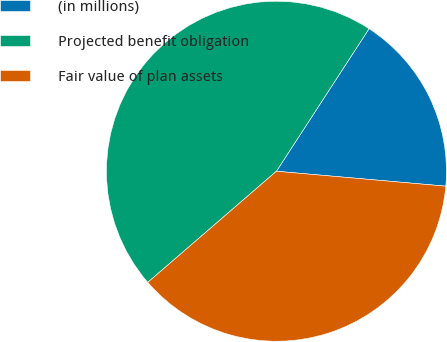Convert chart. <chart><loc_0><loc_0><loc_500><loc_500><pie_chart><fcel>(in millions)<fcel>Projected benefit obligation<fcel>Fair value of plan assets<nl><fcel>17.23%<fcel>45.51%<fcel>37.26%<nl></chart> 